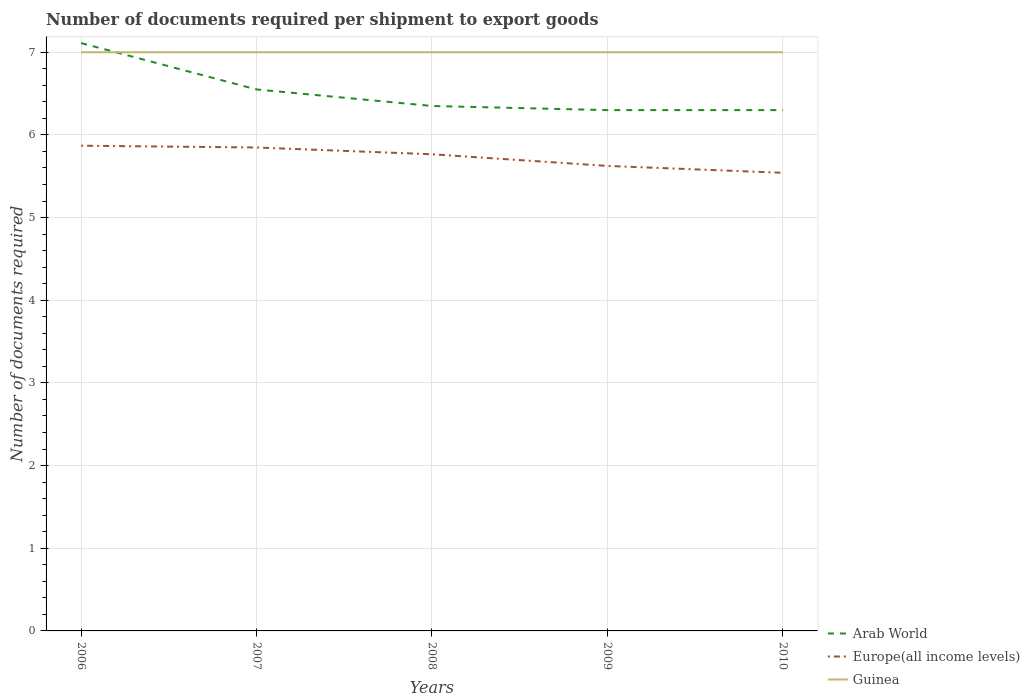Across all years, what is the maximum number of documents required per shipment to export goods in Europe(all income levels)?
Provide a succinct answer. 5.54. In which year was the number of documents required per shipment to export goods in Europe(all income levels) maximum?
Give a very brief answer. 2010. What is the total number of documents required per shipment to export goods in Europe(all income levels) in the graph?
Your response must be concise. 0.22. What is the difference between the highest and the second highest number of documents required per shipment to export goods in Europe(all income levels)?
Your answer should be very brief. 0.33. What is the difference between the highest and the lowest number of documents required per shipment to export goods in Arab World?
Keep it short and to the point. 2. Are the values on the major ticks of Y-axis written in scientific E-notation?
Make the answer very short. No. Does the graph contain any zero values?
Give a very brief answer. No. Does the graph contain grids?
Offer a very short reply. Yes. Where does the legend appear in the graph?
Your response must be concise. Bottom right. How many legend labels are there?
Give a very brief answer. 3. What is the title of the graph?
Offer a terse response. Number of documents required per shipment to export goods. Does "Sao Tome and Principe" appear as one of the legend labels in the graph?
Keep it short and to the point. No. What is the label or title of the X-axis?
Your answer should be compact. Years. What is the label or title of the Y-axis?
Your answer should be compact. Number of documents required. What is the Number of documents required of Arab World in 2006?
Your answer should be very brief. 7.11. What is the Number of documents required of Europe(all income levels) in 2006?
Offer a very short reply. 5.87. What is the Number of documents required of Arab World in 2007?
Give a very brief answer. 6.55. What is the Number of documents required of Europe(all income levels) in 2007?
Your answer should be very brief. 5.85. What is the Number of documents required of Guinea in 2007?
Provide a succinct answer. 7. What is the Number of documents required of Arab World in 2008?
Give a very brief answer. 6.35. What is the Number of documents required of Europe(all income levels) in 2008?
Ensure brevity in your answer.  5.77. What is the Number of documents required of Arab World in 2009?
Keep it short and to the point. 6.3. What is the Number of documents required in Europe(all income levels) in 2009?
Keep it short and to the point. 5.62. What is the Number of documents required of Guinea in 2009?
Make the answer very short. 7. What is the Number of documents required of Arab World in 2010?
Offer a very short reply. 6.3. What is the Number of documents required of Europe(all income levels) in 2010?
Provide a short and direct response. 5.54. What is the Number of documents required in Guinea in 2010?
Give a very brief answer. 7. Across all years, what is the maximum Number of documents required in Arab World?
Offer a terse response. 7.11. Across all years, what is the maximum Number of documents required of Europe(all income levels)?
Your answer should be very brief. 5.87. Across all years, what is the minimum Number of documents required of Arab World?
Your response must be concise. 6.3. Across all years, what is the minimum Number of documents required in Europe(all income levels)?
Ensure brevity in your answer.  5.54. What is the total Number of documents required of Arab World in the graph?
Keep it short and to the point. 32.61. What is the total Number of documents required of Europe(all income levels) in the graph?
Offer a very short reply. 28.65. What is the total Number of documents required in Guinea in the graph?
Offer a very short reply. 35. What is the difference between the Number of documents required of Arab World in 2006 and that in 2007?
Your answer should be compact. 0.56. What is the difference between the Number of documents required in Europe(all income levels) in 2006 and that in 2007?
Your answer should be very brief. 0.02. What is the difference between the Number of documents required of Arab World in 2006 and that in 2008?
Ensure brevity in your answer.  0.76. What is the difference between the Number of documents required in Europe(all income levels) in 2006 and that in 2008?
Your response must be concise. 0.1. What is the difference between the Number of documents required of Guinea in 2006 and that in 2008?
Your answer should be compact. 0. What is the difference between the Number of documents required of Arab World in 2006 and that in 2009?
Offer a terse response. 0.81. What is the difference between the Number of documents required of Europe(all income levels) in 2006 and that in 2009?
Ensure brevity in your answer.  0.24. What is the difference between the Number of documents required in Guinea in 2006 and that in 2009?
Your answer should be compact. 0. What is the difference between the Number of documents required in Arab World in 2006 and that in 2010?
Your answer should be compact. 0.81. What is the difference between the Number of documents required of Europe(all income levels) in 2006 and that in 2010?
Give a very brief answer. 0.33. What is the difference between the Number of documents required of Guinea in 2006 and that in 2010?
Give a very brief answer. 0. What is the difference between the Number of documents required of Arab World in 2007 and that in 2008?
Your response must be concise. 0.2. What is the difference between the Number of documents required of Europe(all income levels) in 2007 and that in 2008?
Make the answer very short. 0.08. What is the difference between the Number of documents required of Arab World in 2007 and that in 2009?
Make the answer very short. 0.25. What is the difference between the Number of documents required in Europe(all income levels) in 2007 and that in 2009?
Offer a terse response. 0.22. What is the difference between the Number of documents required of Guinea in 2007 and that in 2009?
Your answer should be very brief. 0. What is the difference between the Number of documents required of Europe(all income levels) in 2007 and that in 2010?
Give a very brief answer. 0.31. What is the difference between the Number of documents required in Europe(all income levels) in 2008 and that in 2009?
Make the answer very short. 0.14. What is the difference between the Number of documents required in Europe(all income levels) in 2008 and that in 2010?
Provide a succinct answer. 0.22. What is the difference between the Number of documents required in Guinea in 2008 and that in 2010?
Give a very brief answer. 0. What is the difference between the Number of documents required in Europe(all income levels) in 2009 and that in 2010?
Keep it short and to the point. 0.08. What is the difference between the Number of documents required in Arab World in 2006 and the Number of documents required in Europe(all income levels) in 2007?
Offer a very short reply. 1.26. What is the difference between the Number of documents required in Europe(all income levels) in 2006 and the Number of documents required in Guinea in 2007?
Keep it short and to the point. -1.13. What is the difference between the Number of documents required of Arab World in 2006 and the Number of documents required of Europe(all income levels) in 2008?
Keep it short and to the point. 1.35. What is the difference between the Number of documents required in Europe(all income levels) in 2006 and the Number of documents required in Guinea in 2008?
Ensure brevity in your answer.  -1.13. What is the difference between the Number of documents required of Arab World in 2006 and the Number of documents required of Europe(all income levels) in 2009?
Your response must be concise. 1.49. What is the difference between the Number of documents required in Arab World in 2006 and the Number of documents required in Guinea in 2009?
Make the answer very short. 0.11. What is the difference between the Number of documents required of Europe(all income levels) in 2006 and the Number of documents required of Guinea in 2009?
Provide a short and direct response. -1.13. What is the difference between the Number of documents required in Arab World in 2006 and the Number of documents required in Europe(all income levels) in 2010?
Offer a terse response. 1.57. What is the difference between the Number of documents required in Europe(all income levels) in 2006 and the Number of documents required in Guinea in 2010?
Your response must be concise. -1.13. What is the difference between the Number of documents required of Arab World in 2007 and the Number of documents required of Europe(all income levels) in 2008?
Offer a very short reply. 0.78. What is the difference between the Number of documents required in Arab World in 2007 and the Number of documents required in Guinea in 2008?
Offer a very short reply. -0.45. What is the difference between the Number of documents required of Europe(all income levels) in 2007 and the Number of documents required of Guinea in 2008?
Keep it short and to the point. -1.15. What is the difference between the Number of documents required of Arab World in 2007 and the Number of documents required of Europe(all income levels) in 2009?
Provide a short and direct response. 0.93. What is the difference between the Number of documents required in Arab World in 2007 and the Number of documents required in Guinea in 2009?
Your answer should be very brief. -0.45. What is the difference between the Number of documents required of Europe(all income levels) in 2007 and the Number of documents required of Guinea in 2009?
Provide a succinct answer. -1.15. What is the difference between the Number of documents required in Arab World in 2007 and the Number of documents required in Europe(all income levels) in 2010?
Keep it short and to the point. 1.01. What is the difference between the Number of documents required in Arab World in 2007 and the Number of documents required in Guinea in 2010?
Offer a terse response. -0.45. What is the difference between the Number of documents required of Europe(all income levels) in 2007 and the Number of documents required of Guinea in 2010?
Ensure brevity in your answer.  -1.15. What is the difference between the Number of documents required in Arab World in 2008 and the Number of documents required in Europe(all income levels) in 2009?
Provide a succinct answer. 0.72. What is the difference between the Number of documents required in Arab World in 2008 and the Number of documents required in Guinea in 2009?
Provide a short and direct response. -0.65. What is the difference between the Number of documents required of Europe(all income levels) in 2008 and the Number of documents required of Guinea in 2009?
Your answer should be compact. -1.23. What is the difference between the Number of documents required of Arab World in 2008 and the Number of documents required of Europe(all income levels) in 2010?
Provide a short and direct response. 0.81. What is the difference between the Number of documents required of Arab World in 2008 and the Number of documents required of Guinea in 2010?
Provide a short and direct response. -0.65. What is the difference between the Number of documents required in Europe(all income levels) in 2008 and the Number of documents required in Guinea in 2010?
Make the answer very short. -1.23. What is the difference between the Number of documents required of Arab World in 2009 and the Number of documents required of Europe(all income levels) in 2010?
Keep it short and to the point. 0.76. What is the difference between the Number of documents required in Arab World in 2009 and the Number of documents required in Guinea in 2010?
Make the answer very short. -0.7. What is the difference between the Number of documents required in Europe(all income levels) in 2009 and the Number of documents required in Guinea in 2010?
Keep it short and to the point. -1.38. What is the average Number of documents required in Arab World per year?
Your answer should be compact. 6.52. What is the average Number of documents required in Europe(all income levels) per year?
Your response must be concise. 5.73. In the year 2006, what is the difference between the Number of documents required of Arab World and Number of documents required of Europe(all income levels)?
Your answer should be very brief. 1.24. In the year 2006, what is the difference between the Number of documents required in Arab World and Number of documents required in Guinea?
Your response must be concise. 0.11. In the year 2006, what is the difference between the Number of documents required in Europe(all income levels) and Number of documents required in Guinea?
Your response must be concise. -1.13. In the year 2007, what is the difference between the Number of documents required of Arab World and Number of documents required of Europe(all income levels)?
Your response must be concise. 0.7. In the year 2007, what is the difference between the Number of documents required of Arab World and Number of documents required of Guinea?
Your response must be concise. -0.45. In the year 2007, what is the difference between the Number of documents required in Europe(all income levels) and Number of documents required in Guinea?
Make the answer very short. -1.15. In the year 2008, what is the difference between the Number of documents required of Arab World and Number of documents required of Europe(all income levels)?
Offer a very short reply. 0.58. In the year 2008, what is the difference between the Number of documents required of Arab World and Number of documents required of Guinea?
Your response must be concise. -0.65. In the year 2008, what is the difference between the Number of documents required in Europe(all income levels) and Number of documents required in Guinea?
Your answer should be compact. -1.23. In the year 2009, what is the difference between the Number of documents required of Arab World and Number of documents required of Europe(all income levels)?
Offer a terse response. 0.68. In the year 2009, what is the difference between the Number of documents required of Europe(all income levels) and Number of documents required of Guinea?
Keep it short and to the point. -1.38. In the year 2010, what is the difference between the Number of documents required of Arab World and Number of documents required of Europe(all income levels)?
Offer a terse response. 0.76. In the year 2010, what is the difference between the Number of documents required of Arab World and Number of documents required of Guinea?
Give a very brief answer. -0.7. In the year 2010, what is the difference between the Number of documents required in Europe(all income levels) and Number of documents required in Guinea?
Offer a terse response. -1.46. What is the ratio of the Number of documents required of Arab World in 2006 to that in 2007?
Ensure brevity in your answer.  1.09. What is the ratio of the Number of documents required of Europe(all income levels) in 2006 to that in 2007?
Keep it short and to the point. 1. What is the ratio of the Number of documents required in Arab World in 2006 to that in 2008?
Offer a terse response. 1.12. What is the ratio of the Number of documents required of Europe(all income levels) in 2006 to that in 2008?
Offer a very short reply. 1.02. What is the ratio of the Number of documents required in Guinea in 2006 to that in 2008?
Offer a terse response. 1. What is the ratio of the Number of documents required of Arab World in 2006 to that in 2009?
Offer a terse response. 1.13. What is the ratio of the Number of documents required of Europe(all income levels) in 2006 to that in 2009?
Make the answer very short. 1.04. What is the ratio of the Number of documents required of Arab World in 2006 to that in 2010?
Make the answer very short. 1.13. What is the ratio of the Number of documents required of Europe(all income levels) in 2006 to that in 2010?
Provide a succinct answer. 1.06. What is the ratio of the Number of documents required in Arab World in 2007 to that in 2008?
Offer a very short reply. 1.03. What is the ratio of the Number of documents required of Europe(all income levels) in 2007 to that in 2008?
Keep it short and to the point. 1.01. What is the ratio of the Number of documents required in Arab World in 2007 to that in 2009?
Ensure brevity in your answer.  1.04. What is the ratio of the Number of documents required of Europe(all income levels) in 2007 to that in 2009?
Your response must be concise. 1.04. What is the ratio of the Number of documents required in Guinea in 2007 to that in 2009?
Provide a short and direct response. 1. What is the ratio of the Number of documents required in Arab World in 2007 to that in 2010?
Your answer should be compact. 1.04. What is the ratio of the Number of documents required in Europe(all income levels) in 2007 to that in 2010?
Your answer should be compact. 1.06. What is the ratio of the Number of documents required in Arab World in 2008 to that in 2009?
Your response must be concise. 1.01. What is the ratio of the Number of documents required of Europe(all income levels) in 2008 to that in 2009?
Make the answer very short. 1.03. What is the ratio of the Number of documents required of Arab World in 2008 to that in 2010?
Ensure brevity in your answer.  1.01. What is the ratio of the Number of documents required in Europe(all income levels) in 2008 to that in 2010?
Keep it short and to the point. 1.04. What is the ratio of the Number of documents required in Arab World in 2009 to that in 2010?
Your answer should be very brief. 1. What is the ratio of the Number of documents required of Europe(all income levels) in 2009 to that in 2010?
Provide a short and direct response. 1.01. What is the difference between the highest and the second highest Number of documents required in Arab World?
Offer a terse response. 0.56. What is the difference between the highest and the second highest Number of documents required of Europe(all income levels)?
Provide a succinct answer. 0.02. What is the difference between the highest and the second highest Number of documents required of Guinea?
Give a very brief answer. 0. What is the difference between the highest and the lowest Number of documents required of Arab World?
Ensure brevity in your answer.  0.81. What is the difference between the highest and the lowest Number of documents required of Europe(all income levels)?
Your answer should be compact. 0.33. What is the difference between the highest and the lowest Number of documents required in Guinea?
Keep it short and to the point. 0. 